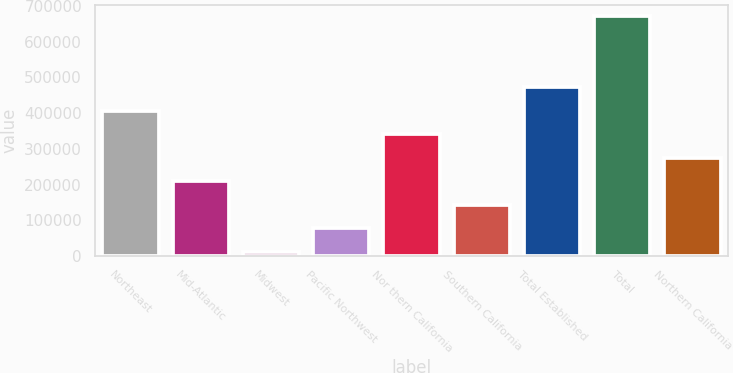<chart> <loc_0><loc_0><loc_500><loc_500><bar_chart><fcel>Northeast<fcel>Mid-Atlantic<fcel>Midwest<fcel>Pacific Northwest<fcel>Nor thern California<fcel>Southern California<fcel>Total Established<fcel>Total<fcel>Northern California<nl><fcel>406853<fcel>208983<fcel>11113<fcel>77069.7<fcel>340896<fcel>143026<fcel>472810<fcel>670680<fcel>274940<nl></chart> 